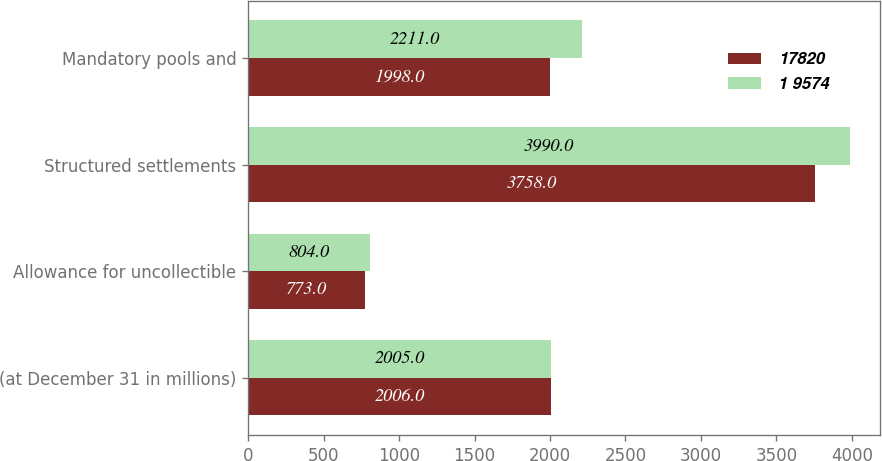<chart> <loc_0><loc_0><loc_500><loc_500><stacked_bar_chart><ecel><fcel>(at December 31 in millions)<fcel>Allowance for uncollectible<fcel>Structured settlements<fcel>Mandatory pools and<nl><fcel>17820<fcel>2006<fcel>773<fcel>3758<fcel>1998<nl><fcel>1 9574<fcel>2005<fcel>804<fcel>3990<fcel>2211<nl></chart> 